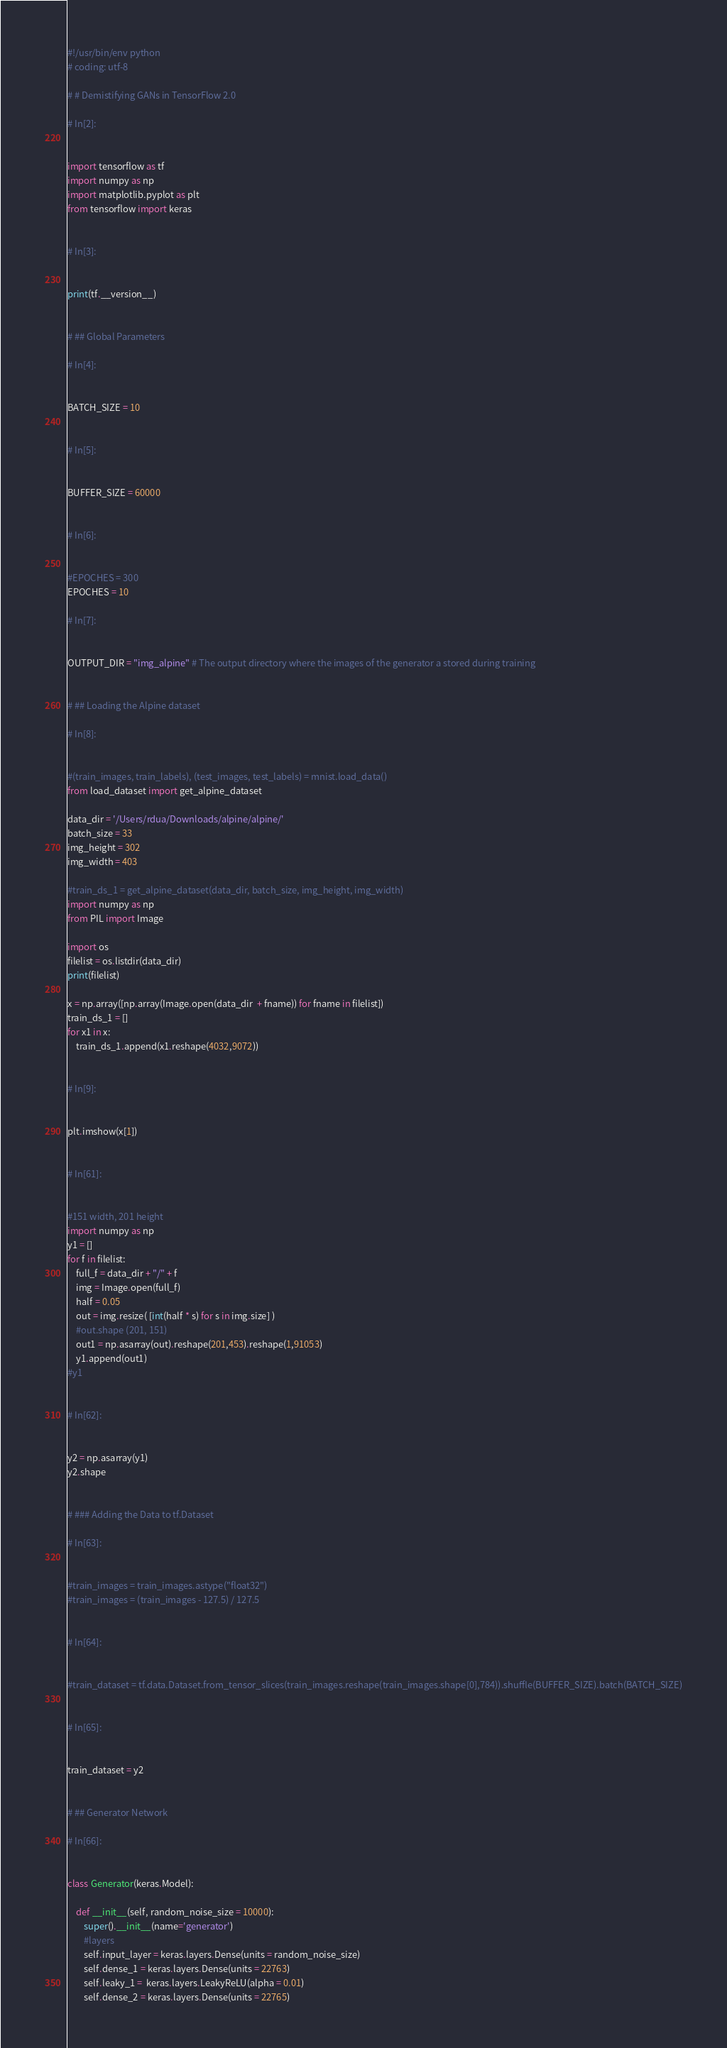Convert code to text. <code><loc_0><loc_0><loc_500><loc_500><_Python_>#!/usr/bin/env python
# coding: utf-8

# # Demistifying GANs in TensorFlow 2.0

# In[2]:


import tensorflow as tf
import numpy as np
import matplotlib.pyplot as plt
from tensorflow import keras


# In[3]:


print(tf.__version__)


# ## Global Parameters

# In[4]:


BATCH_SIZE = 10


# In[5]:


BUFFER_SIZE = 60000


# In[6]:


#EPOCHES = 300
EPOCHES = 10

# In[7]:


OUTPUT_DIR = "img_alpine" # The output directory where the images of the generator a stored during training


# ## Loading the Alpine dataset

# In[8]:


#(train_images, train_labels), (test_images, test_labels) = mnist.load_data()
from load_dataset import get_alpine_dataset

data_dir = '/Users/rdua/Downloads/alpine/alpine/'
batch_size = 33
img_height = 302
img_width = 403

#train_ds_1 = get_alpine_dataset(data_dir, batch_size, img_height, img_width)
import numpy as np
from PIL import Image

import os
filelist = os.listdir(data_dir)
print(filelist)

x = np.array([np.array(Image.open(data_dir  + fname)) for fname in filelist])
train_ds_1 = []
for x1 in x:
    train_ds_1.append(x1.reshape(4032,9072))


# In[9]:


plt.imshow(x[1])


# In[61]:


#151 width, 201 height
import numpy as np
y1 = []
for f in filelist:
    full_f = data_dir + "/" + f
    img = Image.open(full_f)
    half = 0.05
    out = img.resize( [int(half * s) for s in img.size] )
    #out.shape (201, 151)
    out1 = np.asarray(out).reshape(201,453).reshape(1,91053)
    y1.append(out1)
#y1


# In[62]:


y2 = np.asarray(y1)
y2.shape


# ### Adding the Data to tf.Dataset

# In[63]:


#train_images = train_images.astype("float32")
#train_images = (train_images - 127.5) / 127.5


# In[64]:


#train_dataset = tf.data.Dataset.from_tensor_slices(train_images.reshape(train_images.shape[0],784)).shuffle(BUFFER_SIZE).batch(BATCH_SIZE)


# In[65]:


train_dataset = y2


# ## Generator Network

# In[66]:


class Generator(keras.Model):
    
    def __init__(self, random_noise_size = 10000):
        super().__init__(name='generator')
        #layers
        self.input_layer = keras.layers.Dense(units = random_noise_size)
        self.dense_1 = keras.layers.Dense(units = 22763)
        self.leaky_1 =  keras.layers.LeakyReLU(alpha = 0.01)
        self.dense_2 = keras.layers.Dense(units = 22765)</code> 